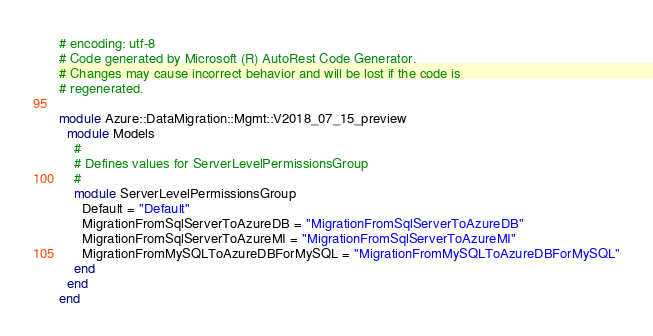<code> <loc_0><loc_0><loc_500><loc_500><_Ruby_># encoding: utf-8
# Code generated by Microsoft (R) AutoRest Code Generator.
# Changes may cause incorrect behavior and will be lost if the code is
# regenerated.

module Azure::DataMigration::Mgmt::V2018_07_15_preview
  module Models
    #
    # Defines values for ServerLevelPermissionsGroup
    #
    module ServerLevelPermissionsGroup
      Default = "Default"
      MigrationFromSqlServerToAzureDB = "MigrationFromSqlServerToAzureDB"
      MigrationFromSqlServerToAzureMI = "MigrationFromSqlServerToAzureMI"
      MigrationFromMySQLToAzureDBForMySQL = "MigrationFromMySQLToAzureDBForMySQL"
    end
  end
end
</code> 